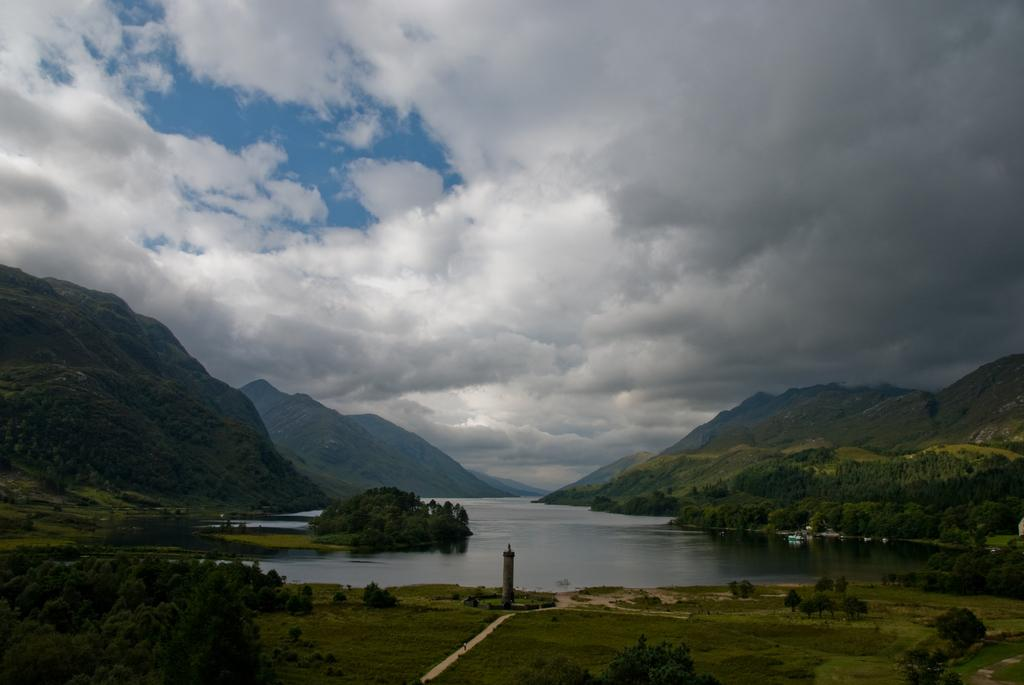What can be seen in the sky in the background of the image? There are clouds visible in the sky in the background of the image. What type of natural landscape can be seen in the image? Hills, trees, grass, and water are visible in the image. What is the composition of the landscape in the image? The landscape includes hills, trees, grass, and water. What type of list can be seen hanging on the trees in the image? There is no list present in the image; it features clouds, hills, trees, grass, and water. Can you hear any bears playing the drum in the image? There are no bears or drums present in the image. 